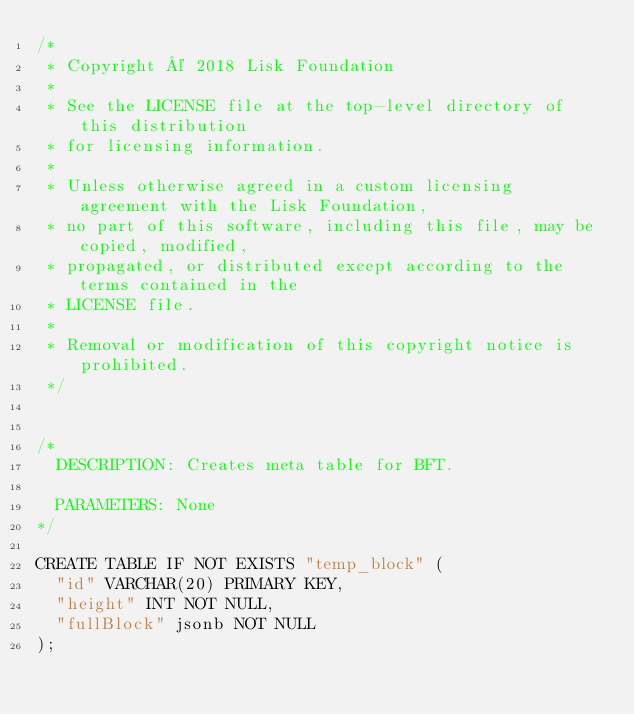Convert code to text. <code><loc_0><loc_0><loc_500><loc_500><_SQL_>/*
 * Copyright © 2018 Lisk Foundation
 *
 * See the LICENSE file at the top-level directory of this distribution
 * for licensing information.
 *
 * Unless otherwise agreed in a custom licensing agreement with the Lisk Foundation,
 * no part of this software, including this file, may be copied, modified,
 * propagated, or distributed except according to the terms contained in the
 * LICENSE file.
 *
 * Removal or modification of this copyright notice is prohibited.
 */


/*
  DESCRIPTION: Creates meta table for BFT.

  PARAMETERS: None
*/

CREATE TABLE IF NOT EXISTS "temp_block" (
	"id" VARCHAR(20) PRIMARY KEY,
  "height" INT NOT NULL,
	"fullBlock" jsonb NOT NULL
);
</code> 